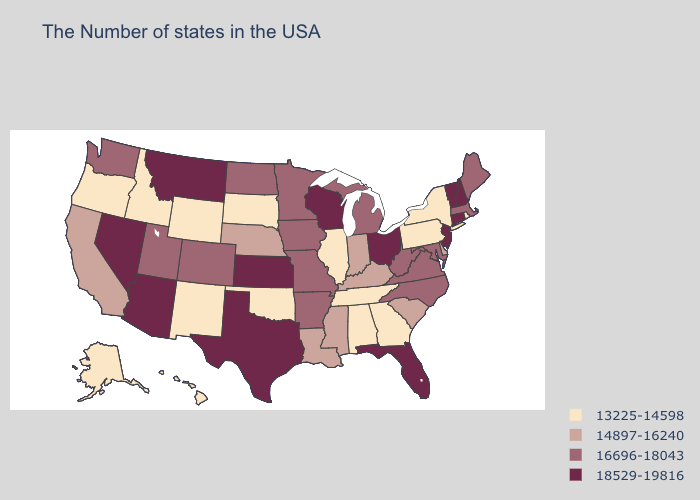Is the legend a continuous bar?
Answer briefly. No. Does the map have missing data?
Be succinct. No. Which states have the highest value in the USA?
Answer briefly. New Hampshire, Vermont, Connecticut, New Jersey, Ohio, Florida, Wisconsin, Kansas, Texas, Montana, Arizona, Nevada. What is the lowest value in the Northeast?
Be succinct. 13225-14598. What is the lowest value in states that border Georgia?
Answer briefly. 13225-14598. Among the states that border Kansas , which have the lowest value?
Quick response, please. Oklahoma. Does the map have missing data?
Write a very short answer. No. What is the value of North Dakota?
Short answer required. 16696-18043. What is the value of New Hampshire?
Keep it brief. 18529-19816. What is the lowest value in the USA?
Concise answer only. 13225-14598. What is the value of Florida?
Be succinct. 18529-19816. Name the states that have a value in the range 14897-16240?
Write a very short answer. Delaware, South Carolina, Kentucky, Indiana, Mississippi, Louisiana, Nebraska, California. Does Florida have the highest value in the South?
Keep it brief. Yes. Which states have the lowest value in the South?
Write a very short answer. Georgia, Alabama, Tennessee, Oklahoma. Does the first symbol in the legend represent the smallest category?
Concise answer only. Yes. 